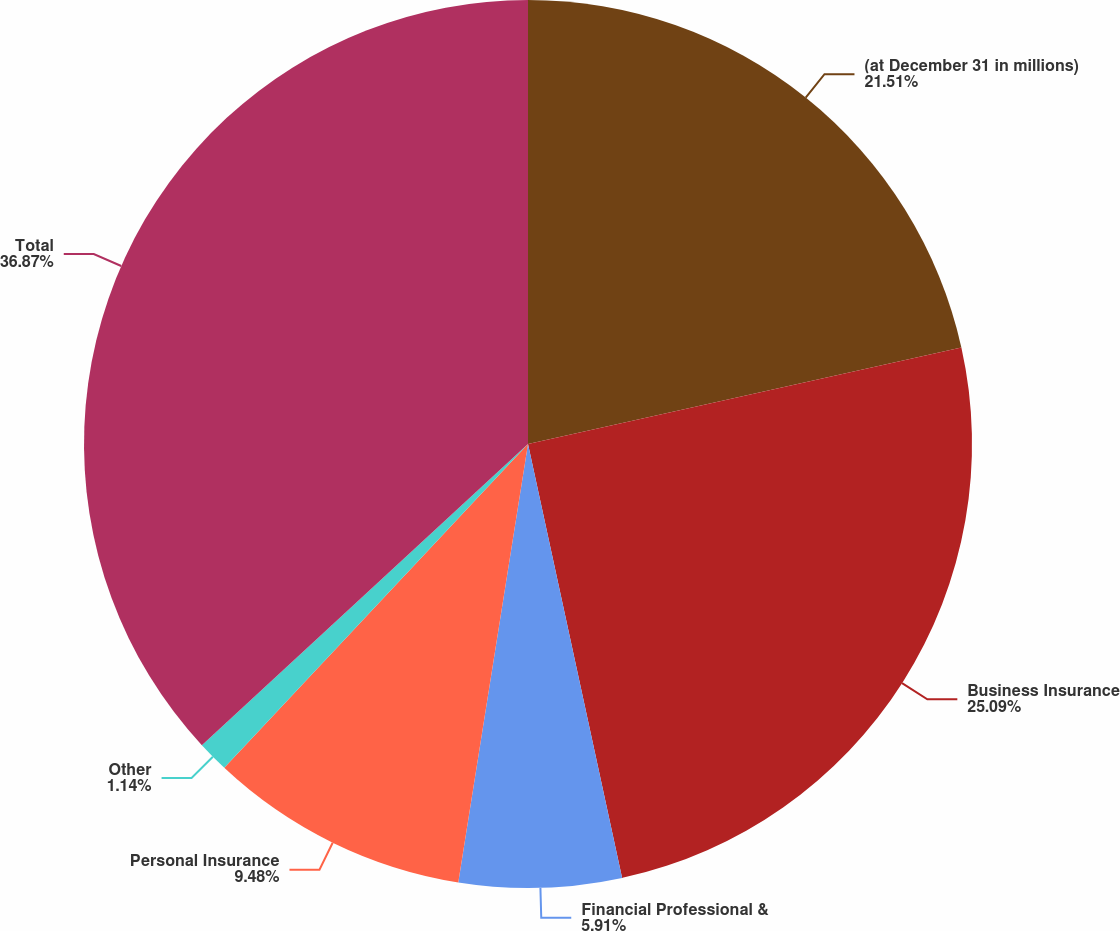<chart> <loc_0><loc_0><loc_500><loc_500><pie_chart><fcel>(at December 31 in millions)<fcel>Business Insurance<fcel>Financial Professional &<fcel>Personal Insurance<fcel>Other<fcel>Total<nl><fcel>21.51%<fcel>25.09%<fcel>5.91%<fcel>9.48%<fcel>1.14%<fcel>36.87%<nl></chart> 